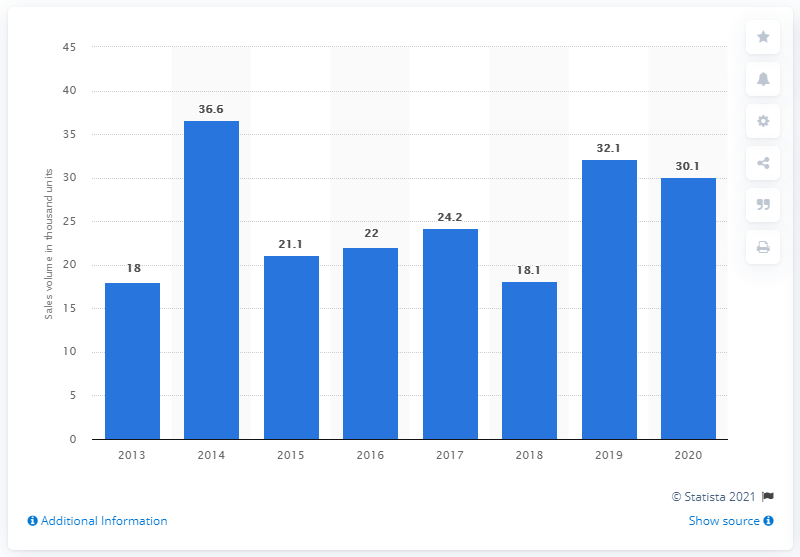Point out several critical features in this image. The total number of Subaru Forester cars sold in Japan from fiscal year 2014 to 2016 was 79,700 units. In fiscal year 2013 to 2020, the highest number of Subaru Forester cars was sold in Japan in 2014. 